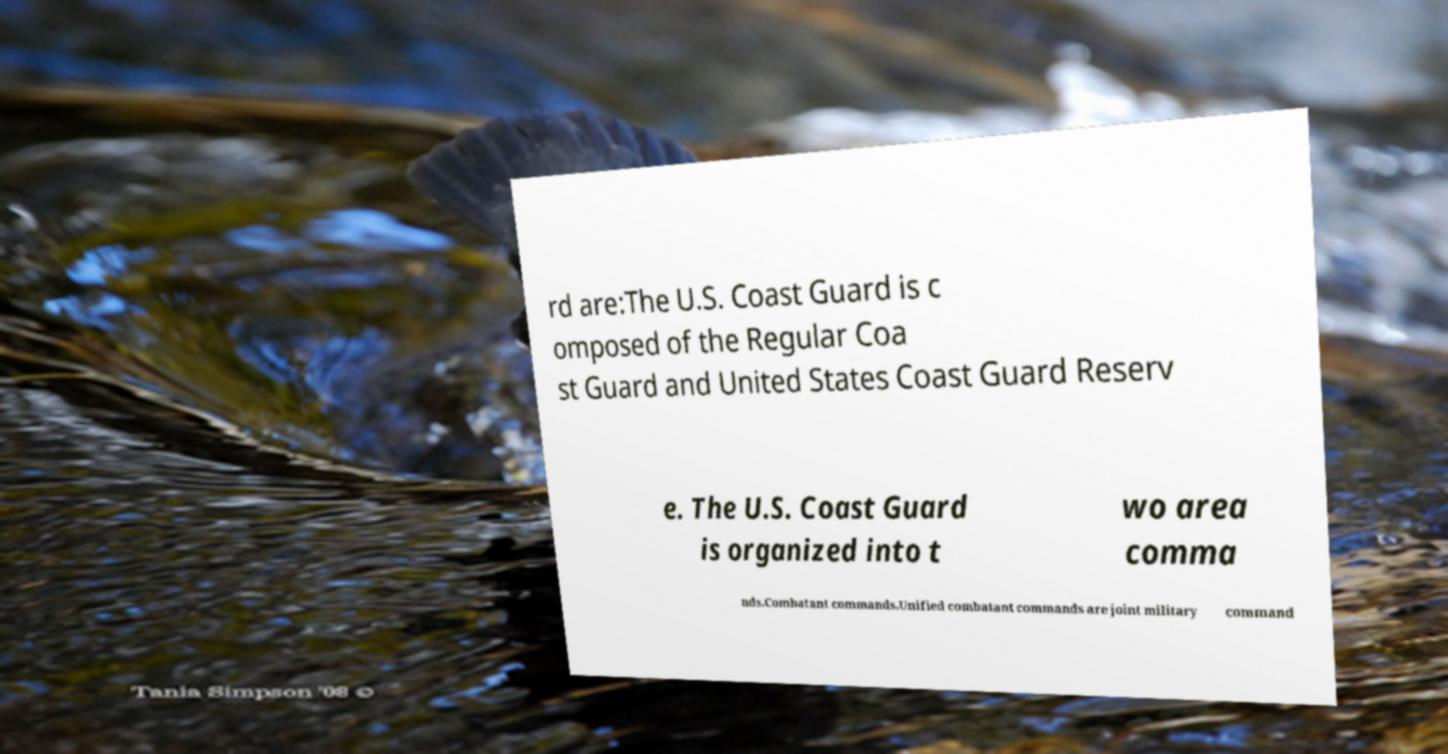There's text embedded in this image that I need extracted. Can you transcribe it verbatim? rd are:The U.S. Coast Guard is c omposed of the Regular Coa st Guard and United States Coast Guard Reserv e. The U.S. Coast Guard is organized into t wo area comma nds.Combatant commands.Unified combatant commands are joint military command 